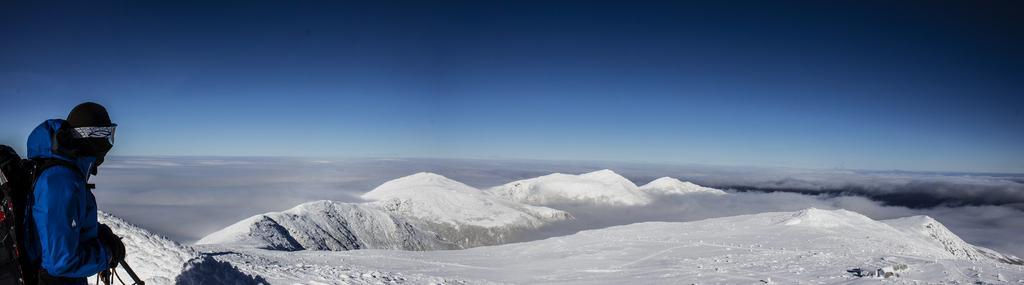What can be seen in the background of the image? In the background of the image, there is a sky, clouds, and hills. What is the person on the left side of the image wearing? The person is wearing a jacket and a backpack. What type of library can be seen in the image? There is no library present in the image. How does the person on the left side of the image express disgust in the image? The person on the left side of the image is not expressing disgust, and there is no indication of any emotion in the image. 